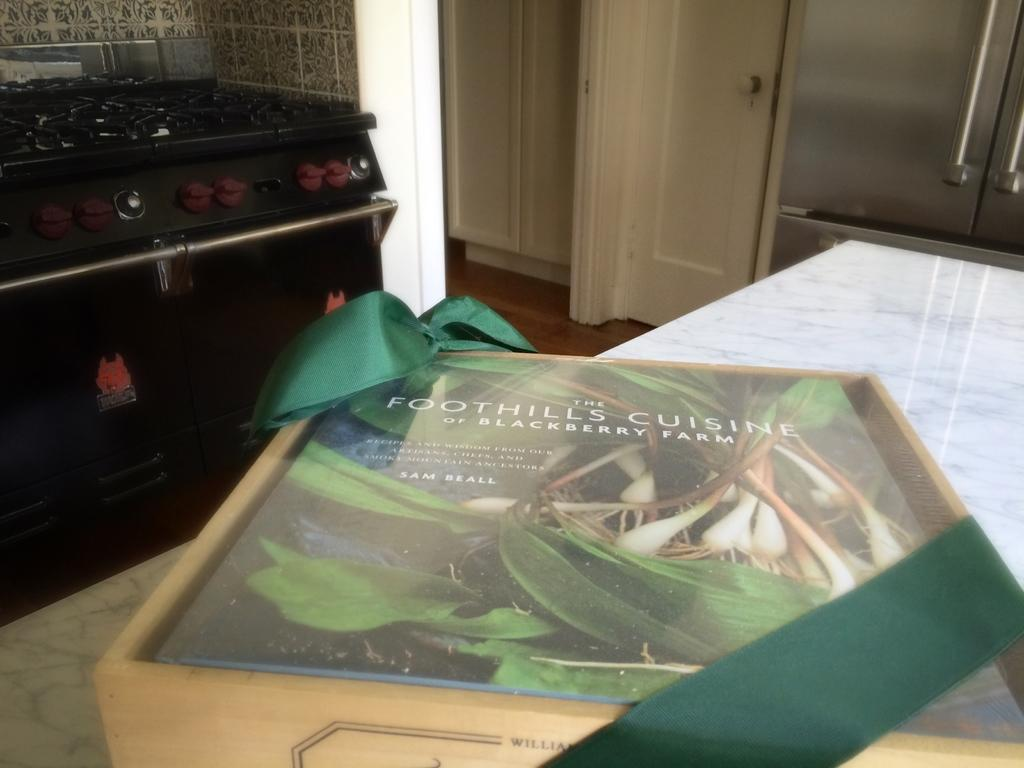<image>
Provide a brief description of the given image. A cookbook named The Foothills Cuisine rests on a countertop. 